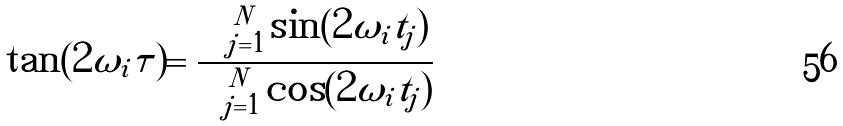Convert formula to latex. <formula><loc_0><loc_0><loc_500><loc_500>\tan ( 2 \omega _ { i } \tau ) = \frac { \sum _ { j = 1 } ^ { N } \sin ( 2 \omega _ { i } t _ { j } ) } { \sum _ { j = 1 } ^ { N } \cos ( 2 \omega _ { i } t _ { j } ) }</formula> 